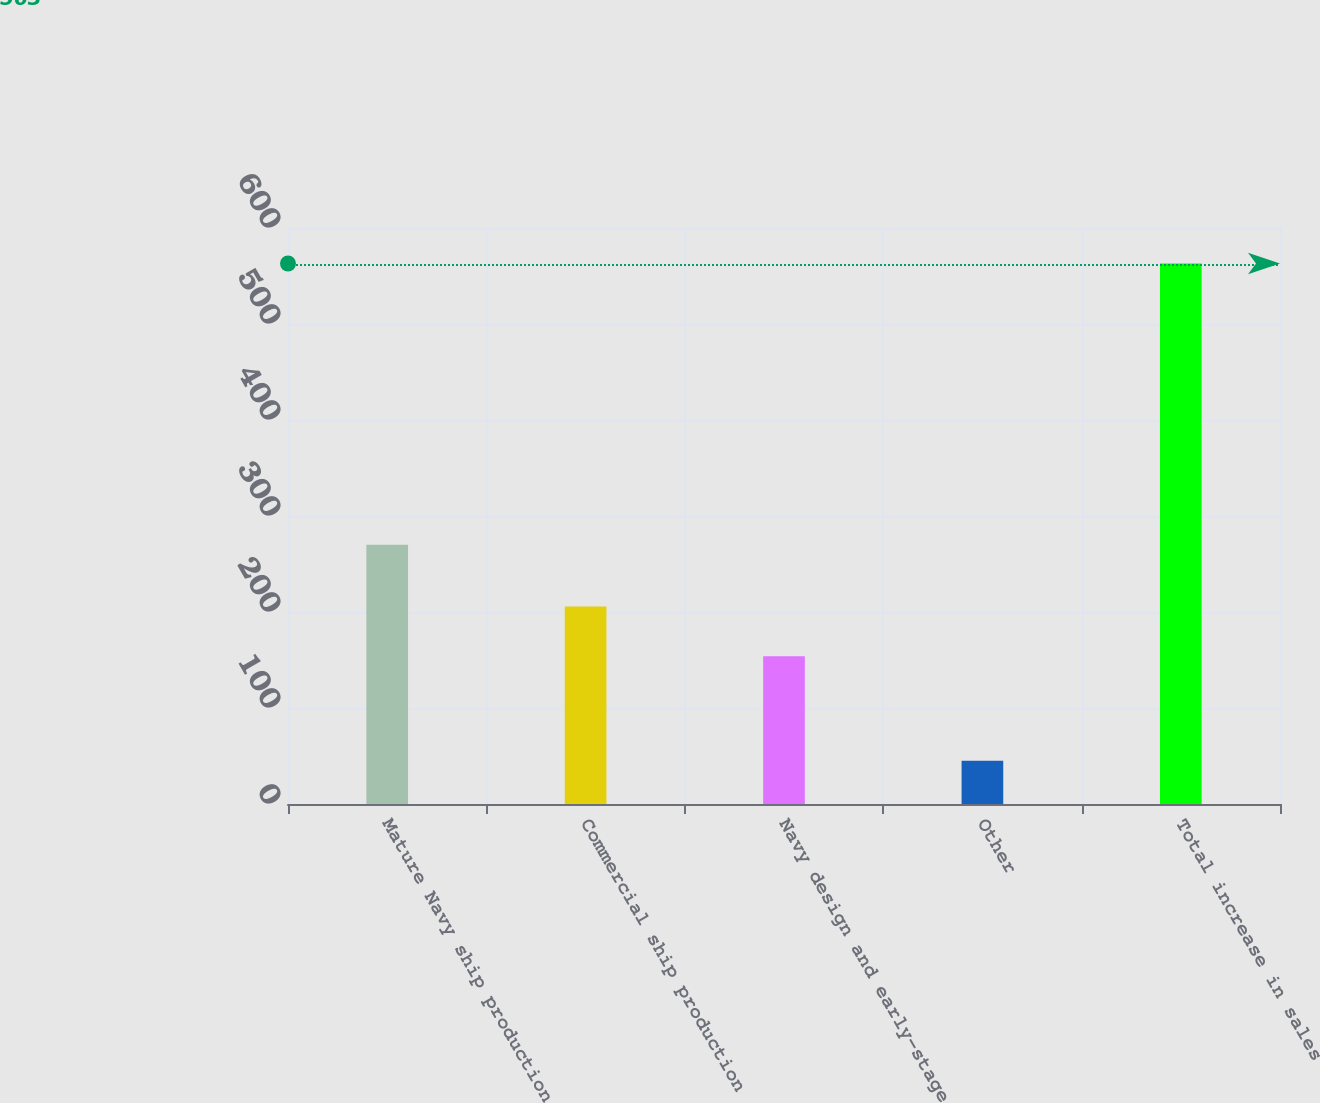<chart> <loc_0><loc_0><loc_500><loc_500><bar_chart><fcel>Mature Navy ship production<fcel>Commercial ship production<fcel>Navy design and early-stage<fcel>Other<fcel>Total increase in sales<nl><fcel>270<fcel>205.8<fcel>154<fcel>45<fcel>563<nl></chart> 